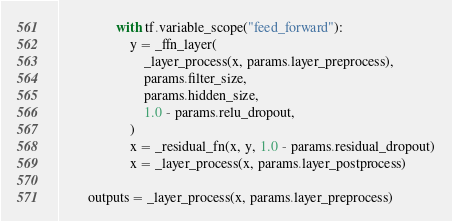Convert code to text. <code><loc_0><loc_0><loc_500><loc_500><_Python_>
                with tf.variable_scope("feed_forward"):
                    y = _ffn_layer(
                        _layer_process(x, params.layer_preprocess),
                        params.filter_size,
                        params.hidden_size,
                        1.0 - params.relu_dropout,
                    )
                    x = _residual_fn(x, y, 1.0 - params.residual_dropout)
                    x = _layer_process(x, params.layer_postprocess)

        outputs = _layer_process(x, params.layer_preprocess)
</code> 